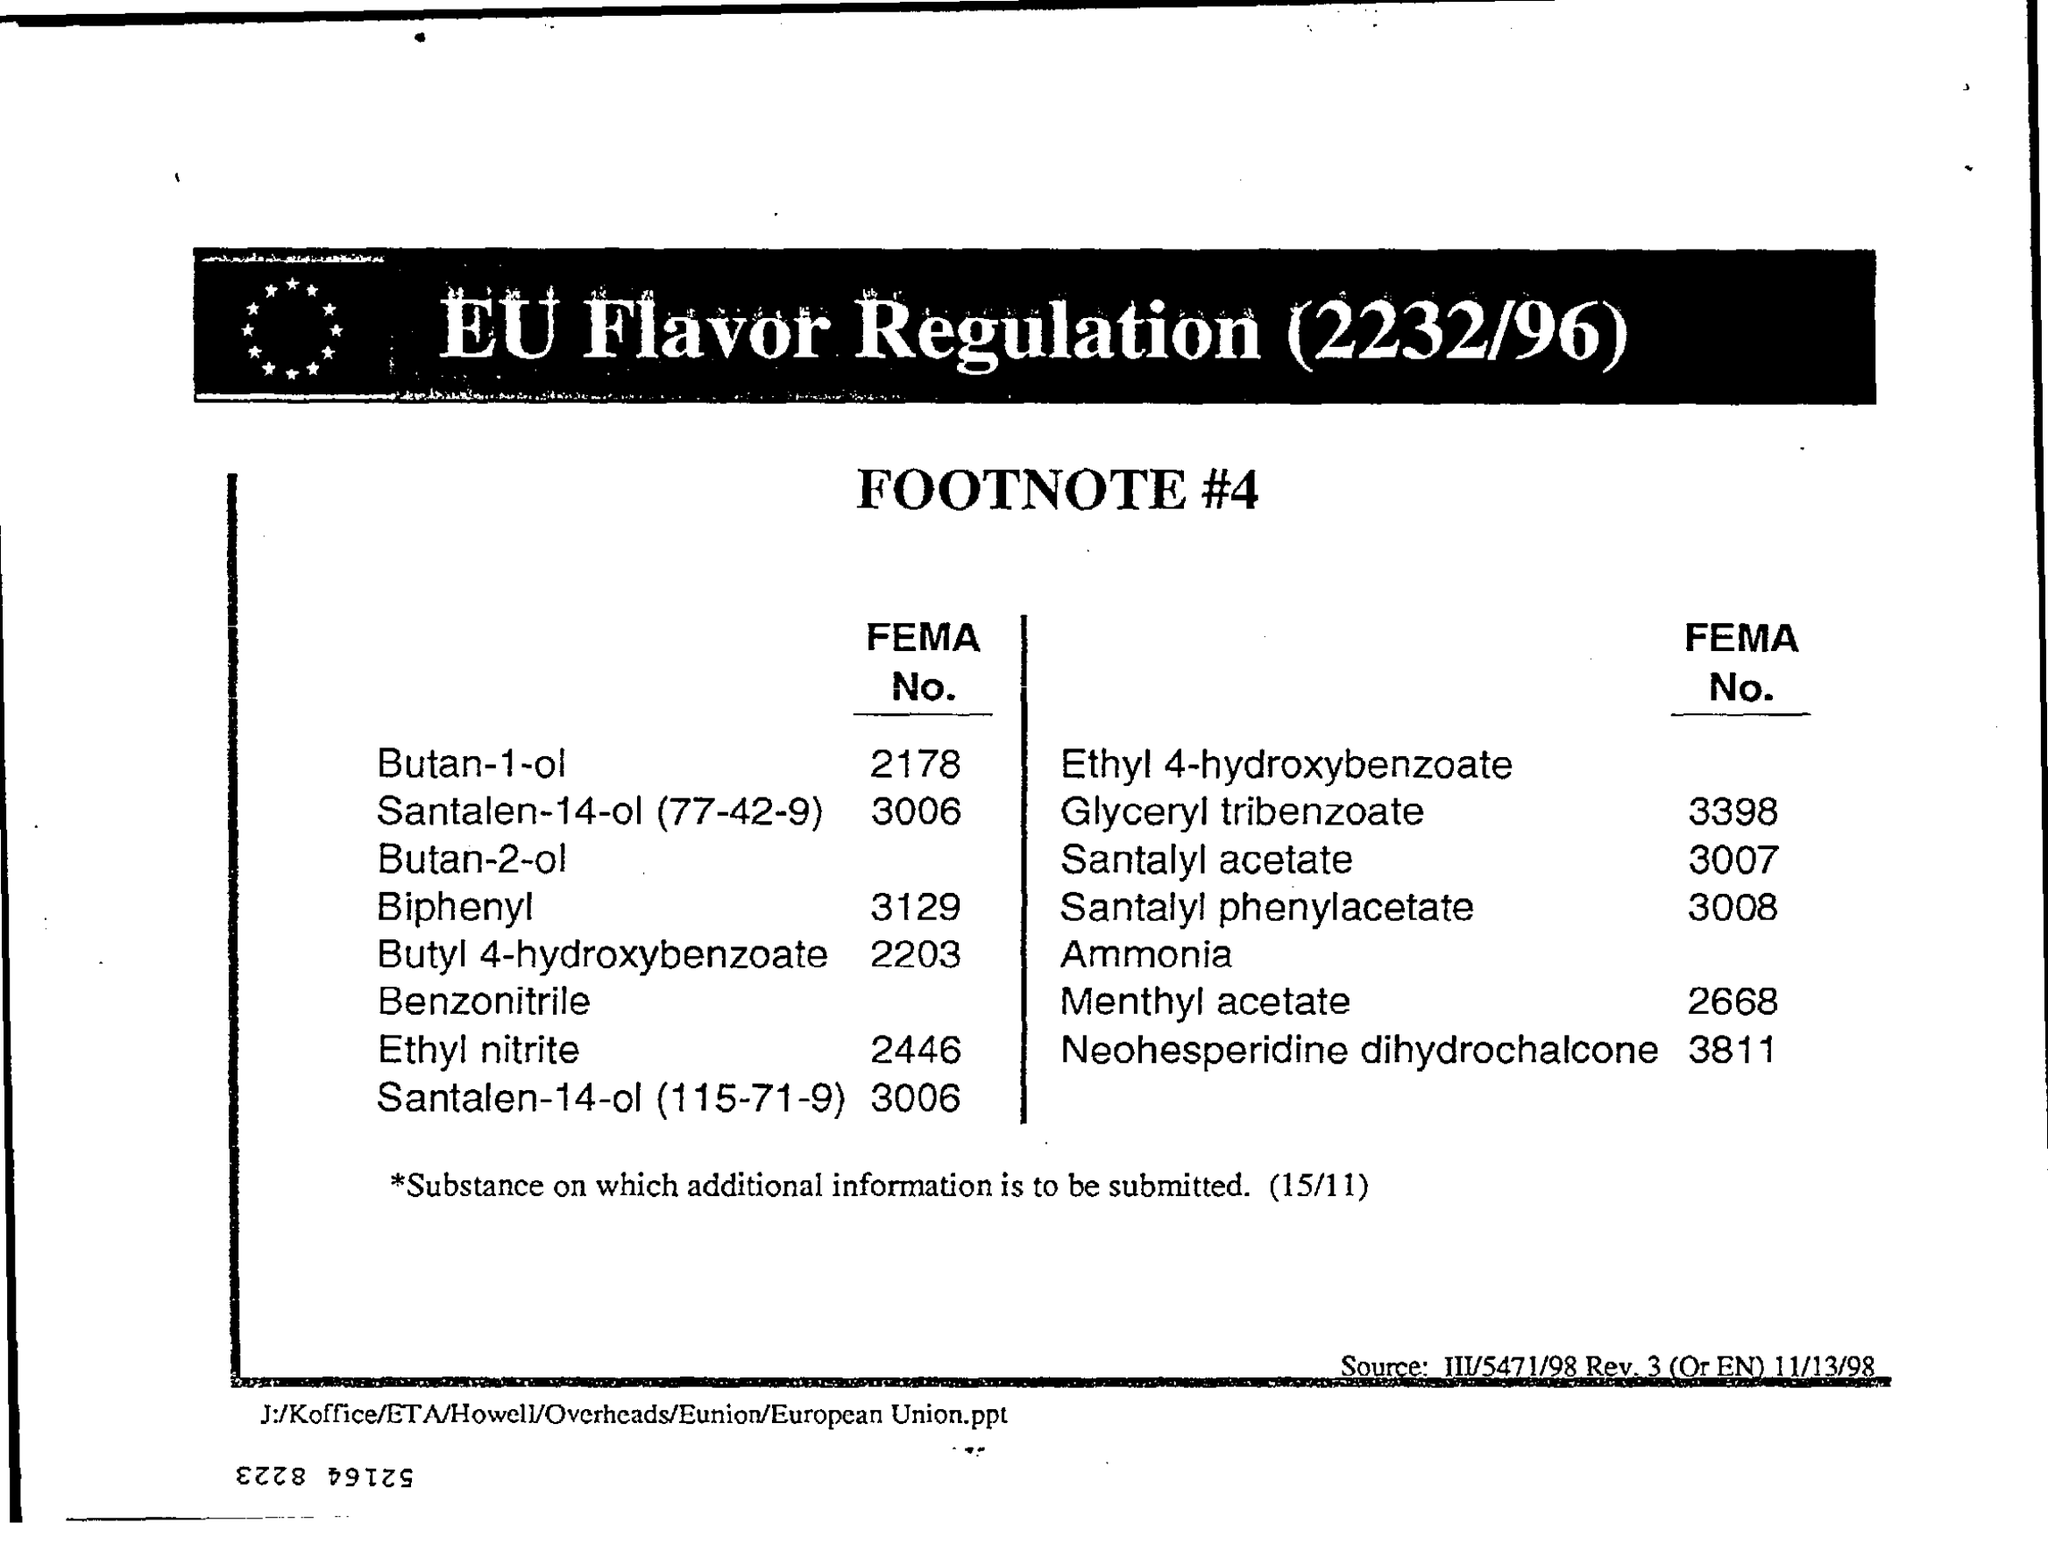Draw attention to some important aspects in this diagram. The FEMA number for menthyl acetate is 2668. The sub-heading of this document is [insert sub-heading here]. The heading of the document is 'EU Flavor Regulation (2232/96).' 